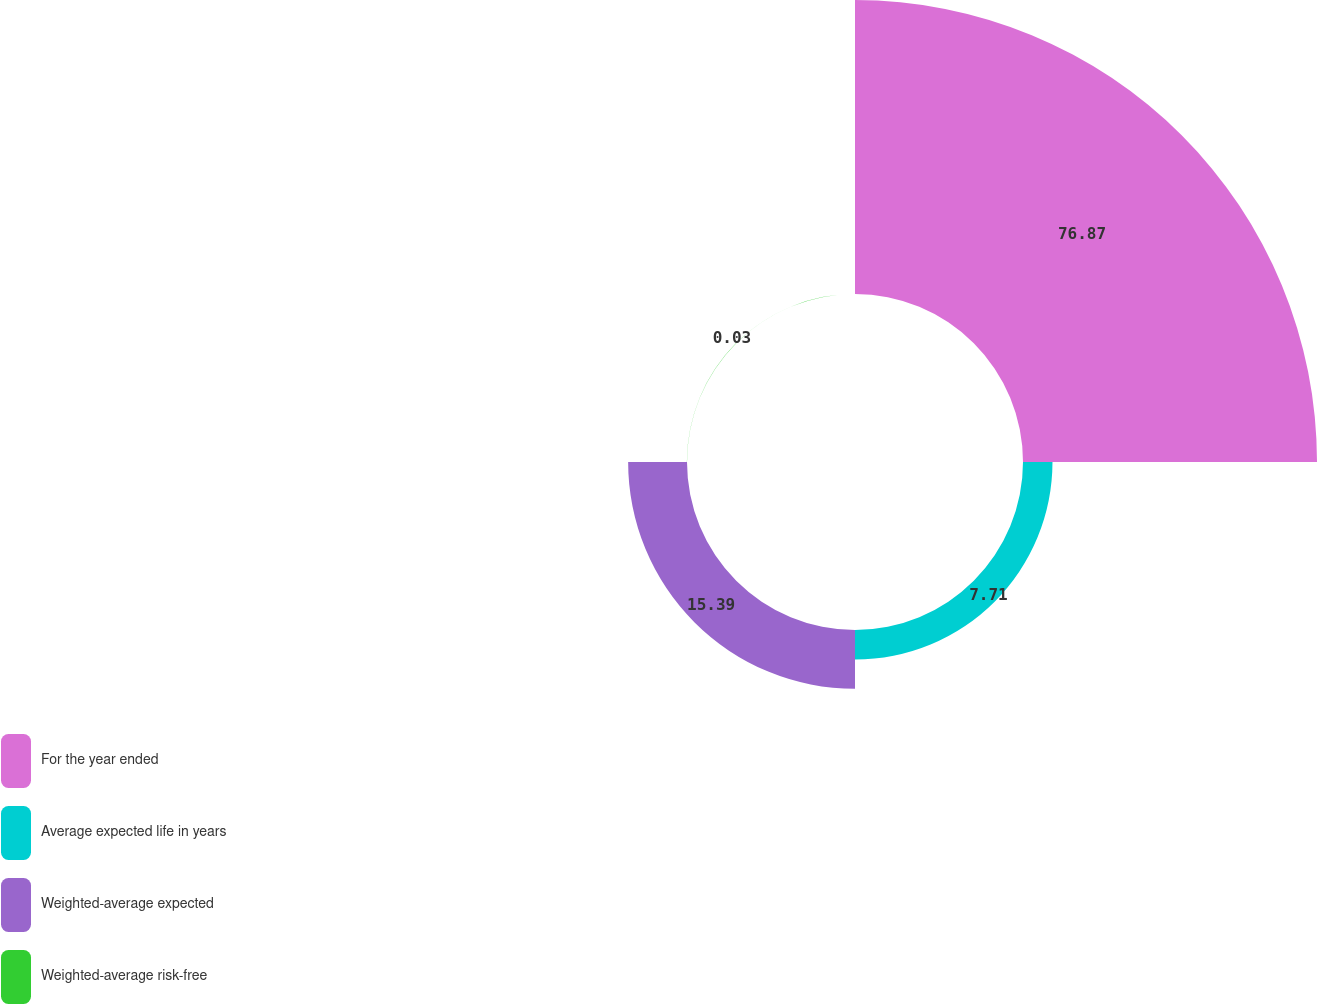Convert chart to OTSL. <chart><loc_0><loc_0><loc_500><loc_500><pie_chart><fcel>For the year ended<fcel>Average expected life in years<fcel>Weighted-average expected<fcel>Weighted-average risk-free<nl><fcel>76.87%<fcel>7.71%<fcel>15.39%<fcel>0.03%<nl></chart> 